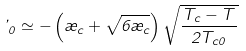Convert formula to latex. <formula><loc_0><loc_0><loc_500><loc_500>\varphi _ { 0 } \simeq - \left ( \rho _ { c } + \sqrt { 6 \rho _ { c } } \right ) \sqrt { \frac { T _ { c } - T } { 2 T _ { c 0 } } }</formula> 